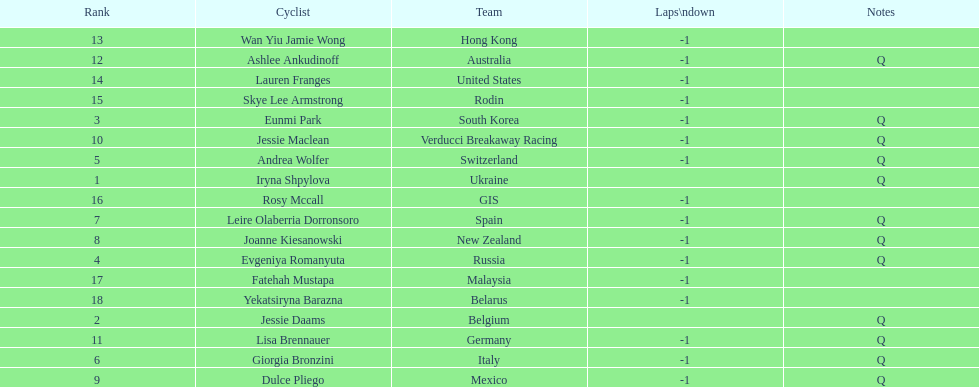Who was the top ranked competitor in this race? Iryna Shpylova. Would you mind parsing the complete table? {'header': ['Rank', 'Cyclist', 'Team', 'Laps\\ndown', 'Notes'], 'rows': [['13', 'Wan Yiu Jamie Wong', 'Hong Kong', '-1', ''], ['12', 'Ashlee Ankudinoff', 'Australia', '-1', 'Q'], ['14', 'Lauren Franges', 'United States', '-1', ''], ['15', 'Skye Lee Armstrong', 'Rodin', '-1', ''], ['3', 'Eunmi Park', 'South Korea', '-1', 'Q'], ['10', 'Jessie Maclean', 'Verducci Breakaway Racing', '-1', 'Q'], ['5', 'Andrea Wolfer', 'Switzerland', '-1', 'Q'], ['1', 'Iryna Shpylova', 'Ukraine', '', 'Q'], ['16', 'Rosy Mccall', 'GIS', '-1', ''], ['7', 'Leire Olaberria Dorronsoro', 'Spain', '-1', 'Q'], ['8', 'Joanne Kiesanowski', 'New Zealand', '-1', 'Q'], ['4', 'Evgeniya Romanyuta', 'Russia', '-1', 'Q'], ['17', 'Fatehah Mustapa', 'Malaysia', '-1', ''], ['18', 'Yekatsiryna Barazna', 'Belarus', '-1', ''], ['2', 'Jessie Daams', 'Belgium', '', 'Q'], ['11', 'Lisa Brennauer', 'Germany', '-1', 'Q'], ['6', 'Giorgia Bronzini', 'Italy', '-1', 'Q'], ['9', 'Dulce Pliego', 'Mexico', '-1', 'Q']]} 